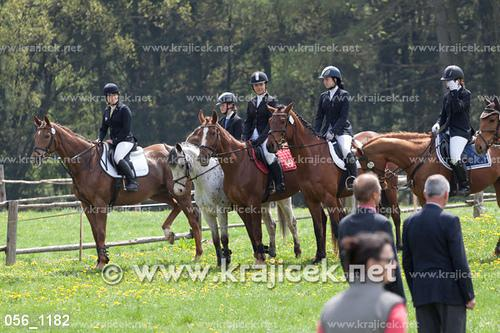Question: how are the horses?
Choices:
A. Running.
B. Eating.
C. Motionless.
D. Walking.
Answer with the letter. Answer: C Question: what are these?
Choices:
A. Cows.
B. Donkeys.
C. Goats.
D. Horses.
Answer with the letter. Answer: D 